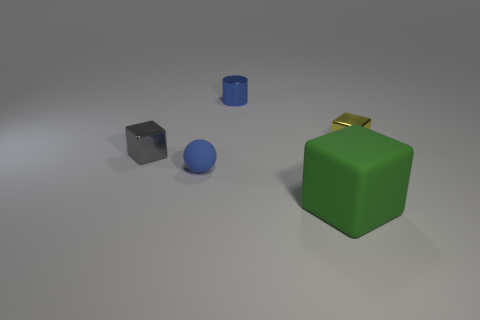Is there a green object that has the same material as the tiny blue ball?
Offer a very short reply. Yes. There is a matte object that is to the right of the small cylinder that is behind the matte thing that is in front of the small blue ball; what color is it?
Provide a short and direct response. Green. Do the small blue object to the left of the blue shiny cylinder and the block that is in front of the gray thing have the same material?
Give a very brief answer. Yes. There is a tiny metal object that is on the right side of the big object; what is its shape?
Ensure brevity in your answer.  Cube. What number of things are small brown objects or blocks to the left of the small blue shiny thing?
Your response must be concise. 1. Does the tiny blue ball have the same material as the tiny blue cylinder?
Keep it short and to the point. No. Are there an equal number of tiny blue things behind the rubber ball and yellow cubes in front of the green block?
Your answer should be very brief. No. There is a tiny gray thing; what number of things are to the right of it?
Provide a succinct answer. 4. What number of things are either small balls or blue objects?
Offer a very short reply. 2. What number of yellow things are the same size as the rubber sphere?
Offer a terse response. 1. 